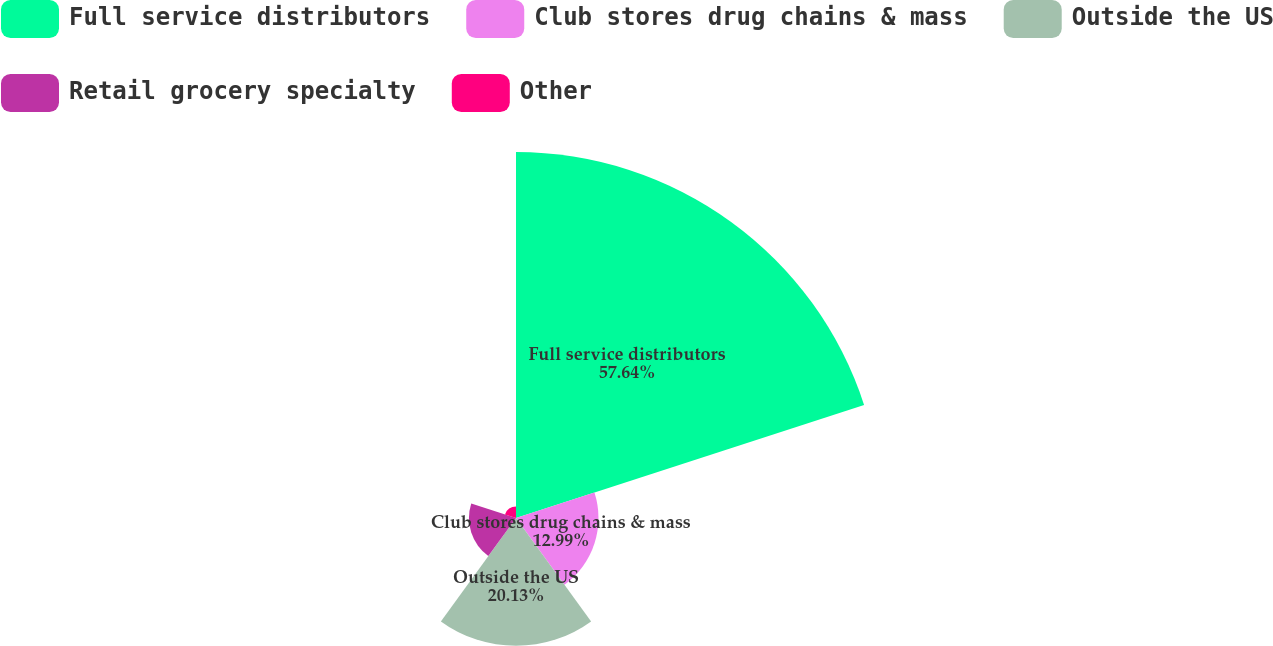Convert chart. <chart><loc_0><loc_0><loc_500><loc_500><pie_chart><fcel>Full service distributors<fcel>Club stores drug chains & mass<fcel>Outside the US<fcel>Retail grocery specialty<fcel>Other<nl><fcel>57.64%<fcel>12.99%<fcel>20.13%<fcel>7.41%<fcel>1.83%<nl></chart> 